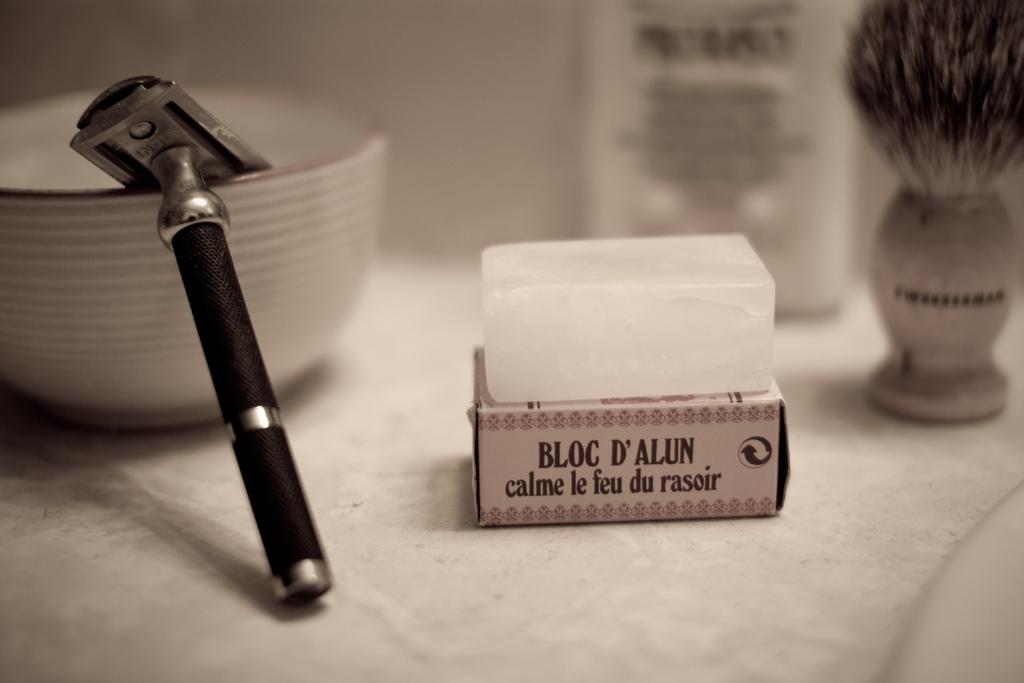What type of block is written on the box?
Ensure brevity in your answer.  Bloc d'alun. 